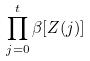<formula> <loc_0><loc_0><loc_500><loc_500>\prod _ { j = 0 } ^ { t } \beta [ Z ( j ) ]</formula> 